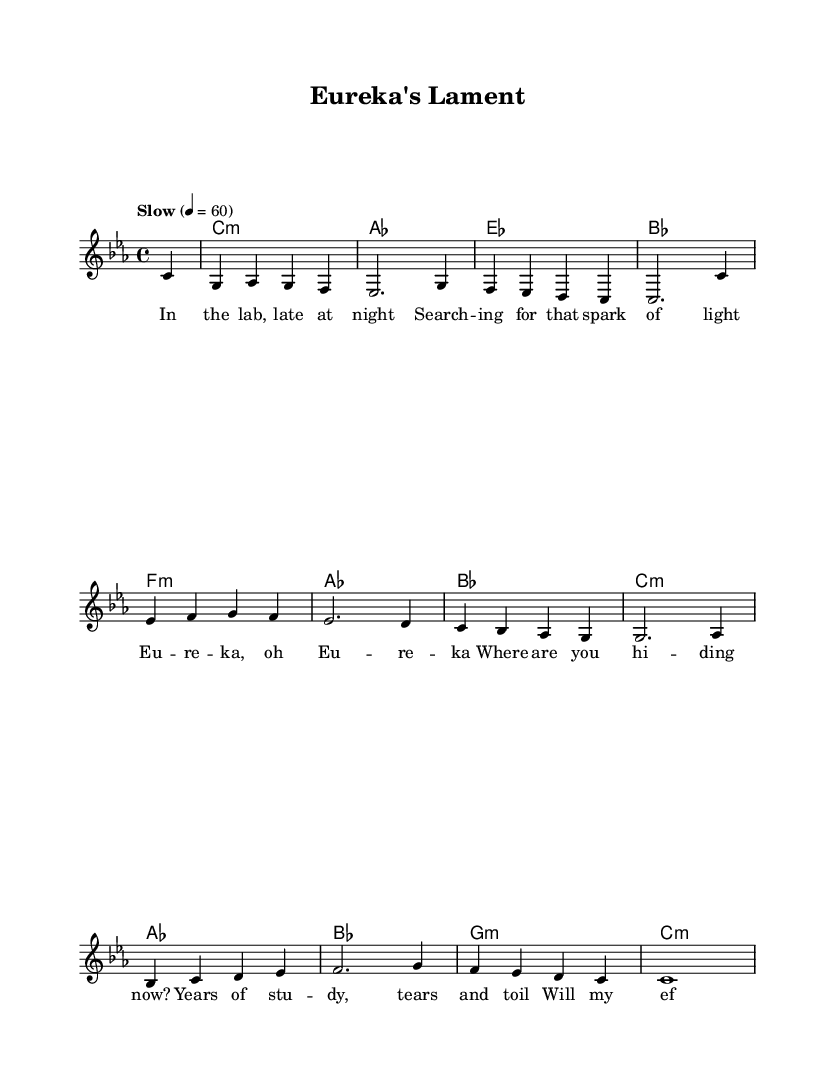What is the key signature of this music? The key signature indicated is C minor, which shows three flats (B flat, E flat, A flat).
Answer: C minor What is the time signature of this music? The time signature shown at the beginning is 4/4, meaning there are four beats in each measure.
Answer: 4/4 What is the tempo marking for this piece? The tempo marking indicates "Slow" with a metronome marking of 60 beats per minute.
Answer: Slow, 60 How many measures does the melody section have? By counting the melody notations, there are 12 measures in total present in the melody section.
Answer: 12 Which chord follows the initial C minor chord in the progression? The chord progression starts with C minor followed by A flat, as seen in the chord mode section.
Answer: A flat What emotional themes are expressed in the lyrics? The lyrics convey themes of searching and longing for insight and understanding in a scientific journey, reflected in the use of phrases like "spark of light" and "tears and toil".
Answer: Searching, longing What type of musical form does this piece take? The structure aligns with typical ballad forms, which often tell a story through verses, and here it narrates the emotional journey of a scientist.
Answer: Ballad 